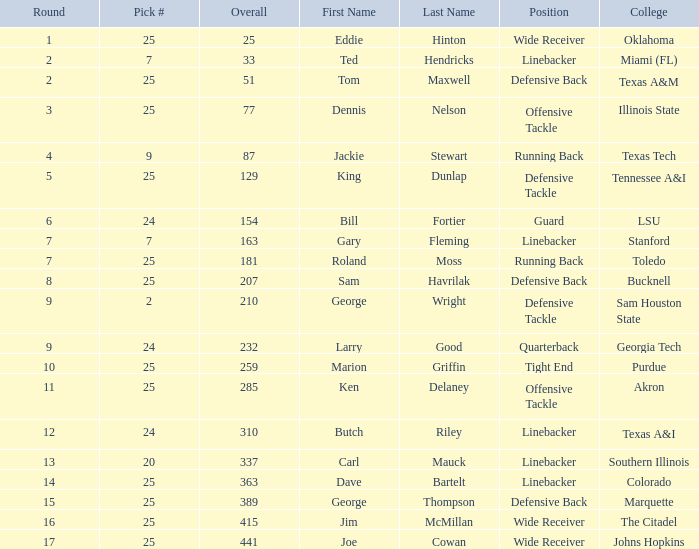Round larger than 6, and a Pick # smaller than 25, and a College of southern Illinois has what position? Linebacker. 